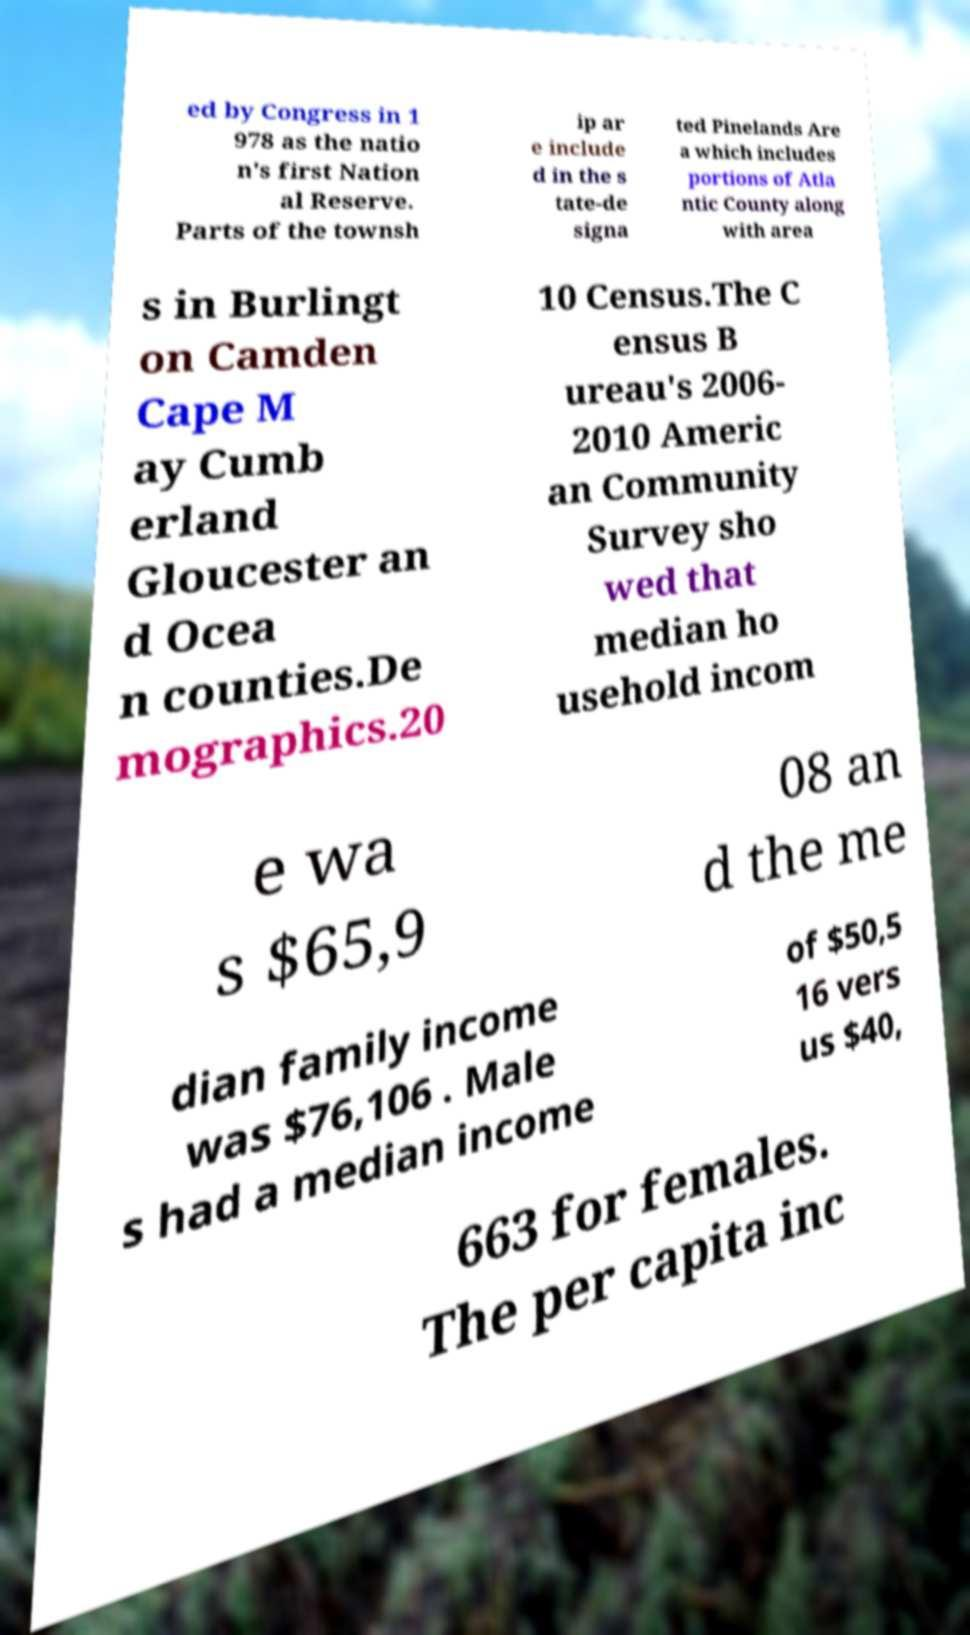What messages or text are displayed in this image? I need them in a readable, typed format. ed by Congress in 1 978 as the natio n's first Nation al Reserve. Parts of the townsh ip ar e include d in the s tate-de signa ted Pinelands Are a which includes portions of Atla ntic County along with area s in Burlingt on Camden Cape M ay Cumb erland Gloucester an d Ocea n counties.De mographics.20 10 Census.The C ensus B ureau's 2006- 2010 Americ an Community Survey sho wed that median ho usehold incom e wa s $65,9 08 an d the me dian family income was $76,106 . Male s had a median income of $50,5 16 vers us $40, 663 for females. The per capita inc 